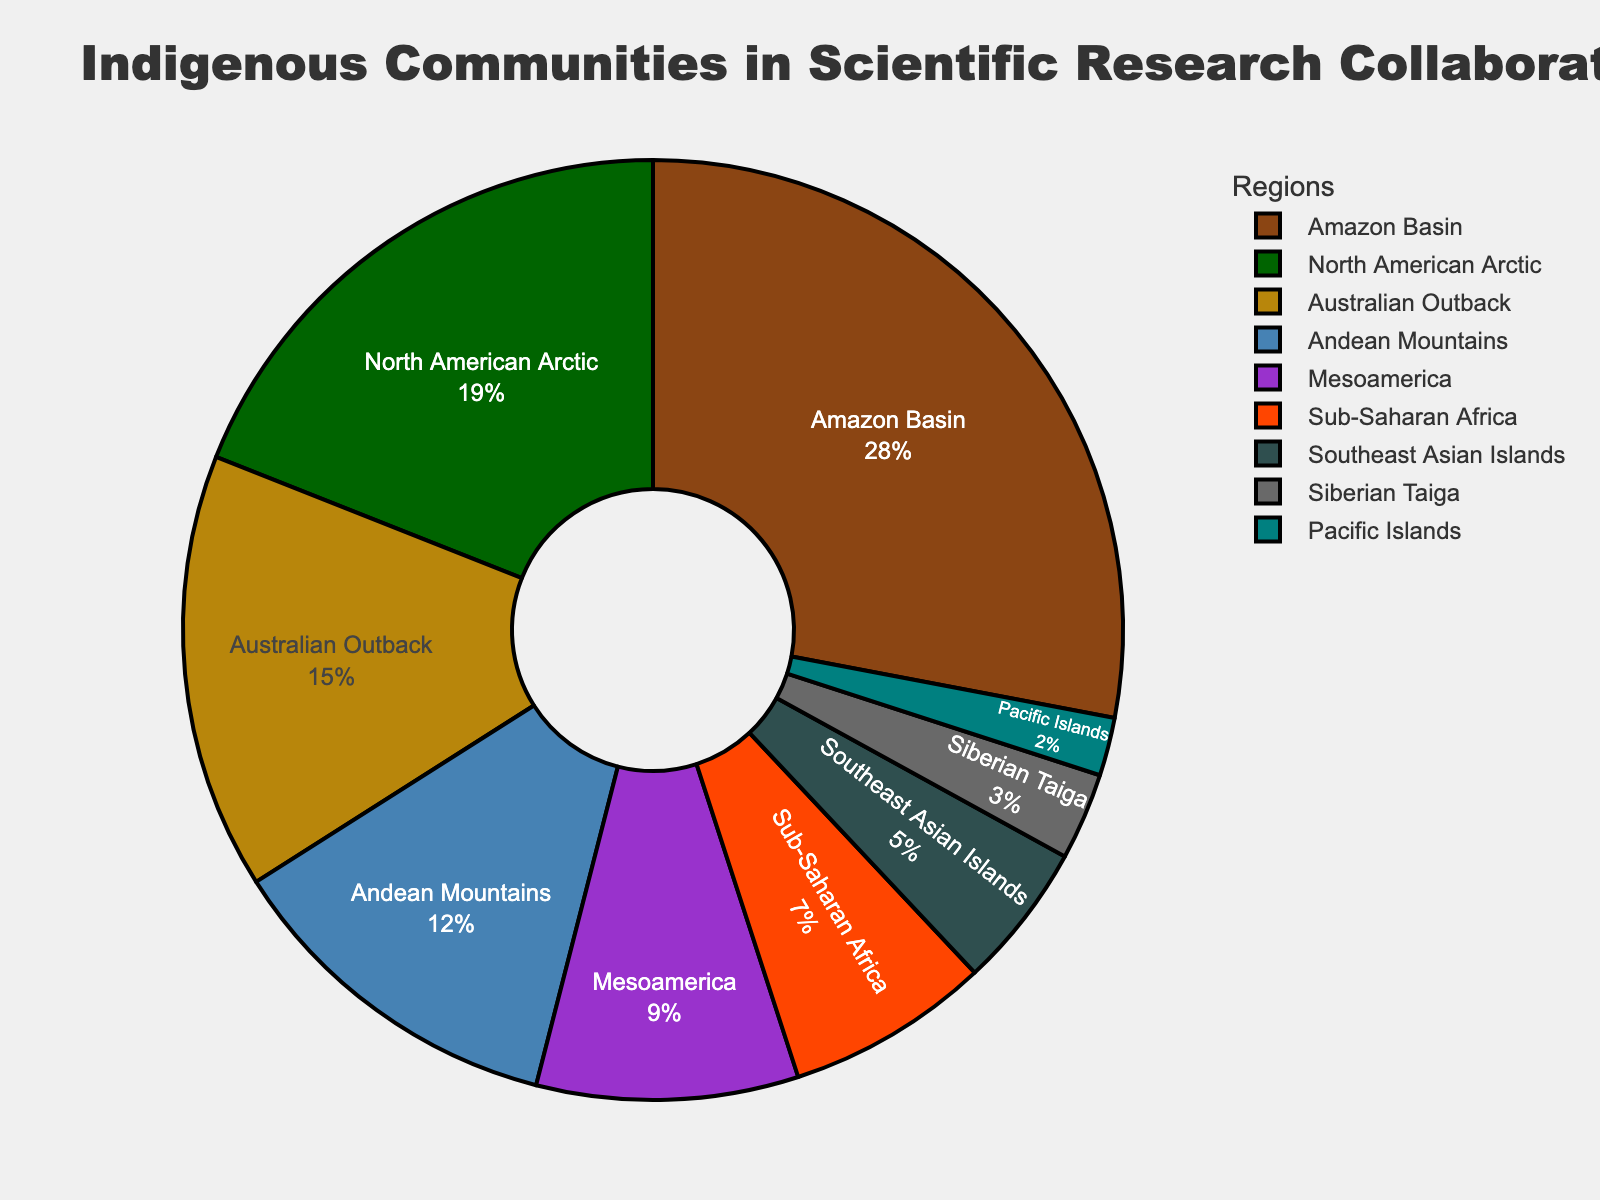what percentage of scientific research collaborations involve indigenous communities from the Amazon Basin compared to North American Arctic? The pie chart shows that the Amazon Basin accounts for 28% and the North American Arctic for 19% of research collaborations. The difference is calculated as 28% - 19%.
Answer: 9% which region has the smallest involvement in scientific research collaborations? The pie chart shows that the Pacific Islands have the smallest involvement with 2%.
Answer: Pacific Islands what is the combined percentage of the regions Amazon Basin, Mesoamerica, and Sub-Saharan Africa? The percentages for Amazon Basin, Mesoamerica, and Sub-Saharan Africa are 28%, 9%, and 7%, respectively. Summing them results in 28% + 9% + 7% = 44%.
Answer: 44% how many regions have an involvement percentage of 10% or higher? From the pie chart, regions with 10% or higher involvement are Amazon Basin (28%), North American Arctic (19%), Australian Outback (15%), and Andean Mountains (12%). This makes a total of 4 regions.
Answer: 4 which region has twice the involvement as the Southeast Asian Islands? Southeast Asian Islands have 5% involvement. The Australian Outback has 15% which is three times more, not twice. The North American Arctic has 19% but it is not twice. Hence, the Australian Outback with 15% is the closest region to twice the 5% of Southeast Asian Islands.
Answer: Australian Outback what is the median percentage of involvement in scientific research collaborations across these regions? To find the median, list the percentages in sorted order: 2%, 3%, 5%, 7%, 9%, 12%, 15%, 19%, 28%. The median is the middle value, which is 9%.
Answer: 9% which color in the pie chart represents the North American Arctic region? The pie chart shows North American Arctic in the second slot; locating its corresponding color in the chart legend, it is green.
Answer: green 